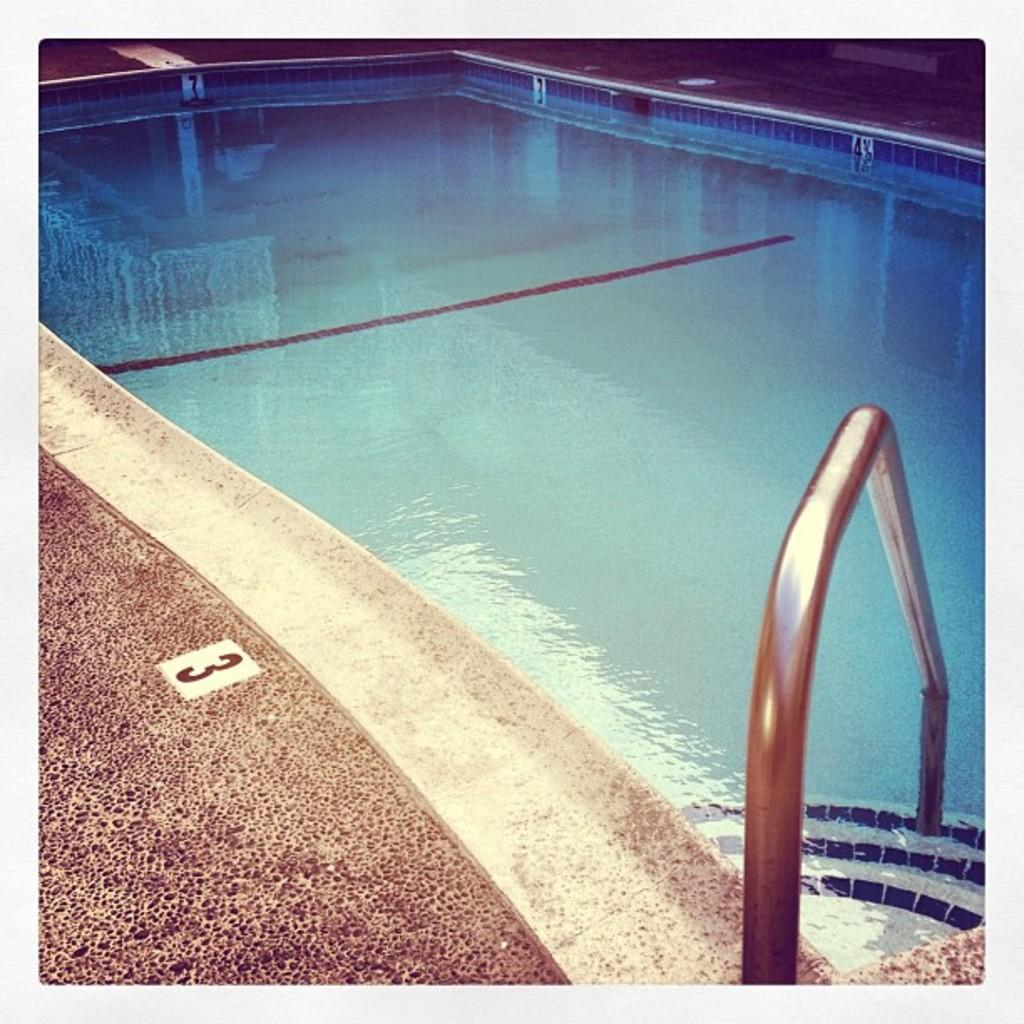What is the main feature of the image? There is a swimming pool in the image. How many eggs are floating in the swimming pool in the image? There are no eggs present in the swimming pool in the image. Is there a cover on the swimming pool in the image? The provided facts do not mention a cover on the swimming pool, so we cannot definitively answer this question. 